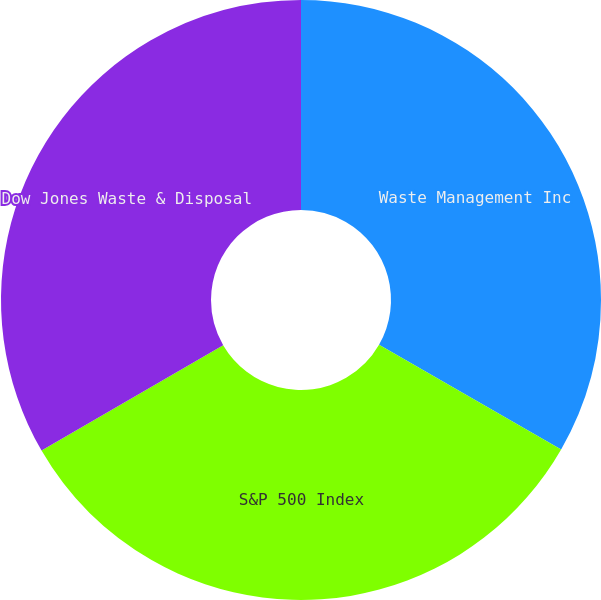<chart> <loc_0><loc_0><loc_500><loc_500><pie_chart><fcel>Waste Management Inc<fcel>S&P 500 Index<fcel>Dow Jones Waste & Disposal<nl><fcel>33.3%<fcel>33.33%<fcel>33.37%<nl></chart> 